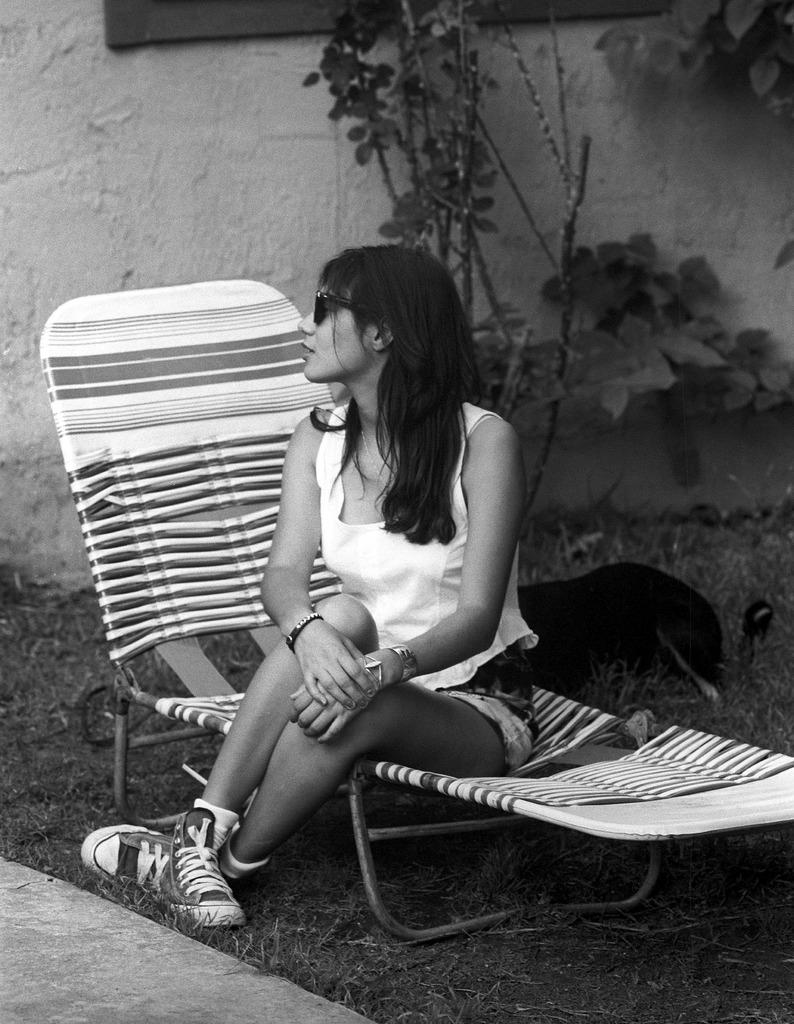What is the woman doing in the image? The woman is sitting on a chair in the image. Can you describe the animal in the image? Unfortunately, the facts provided do not mention any specific details about the animal. However, we can confirm that there is an animal present in the image. What does the caption say about the woman and the animal in the image? There is no caption present in the image, so we cannot determine what it might say about the woman and the animal. 